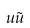<formula> <loc_0><loc_0><loc_500><loc_500>u \tilde { u }</formula> 